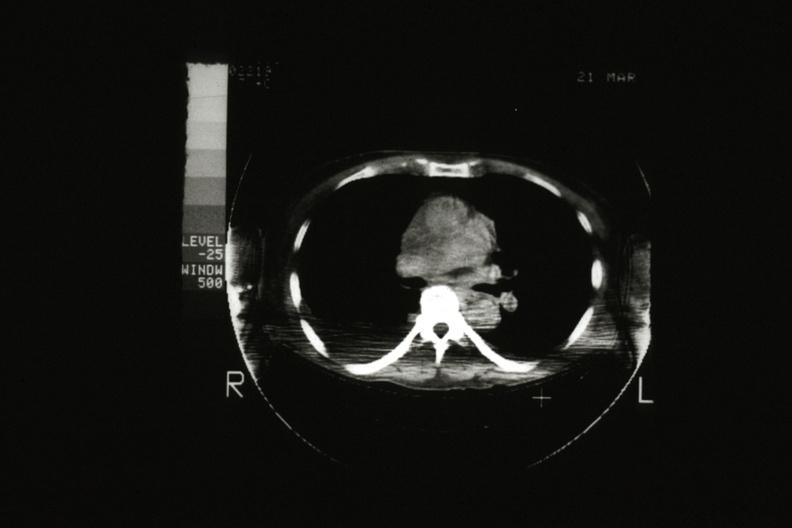what is present?
Answer the question using a single word or phrase. Malignant thymoma 